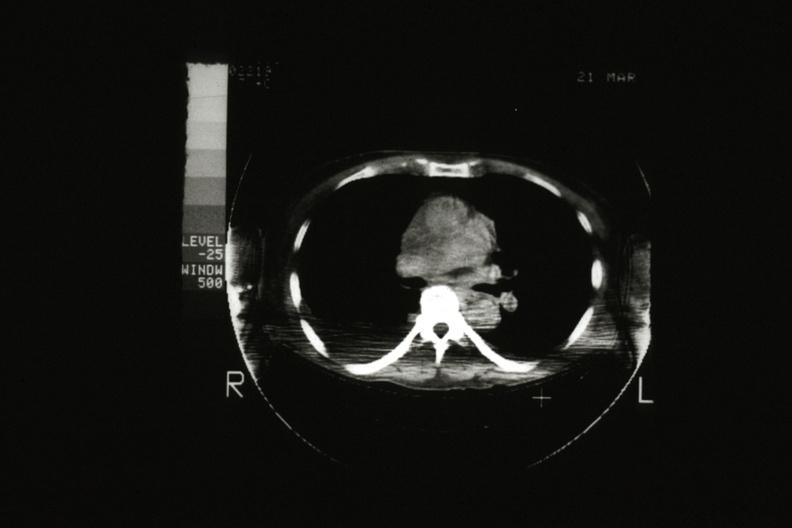what is present?
Answer the question using a single word or phrase. Malignant thymoma 